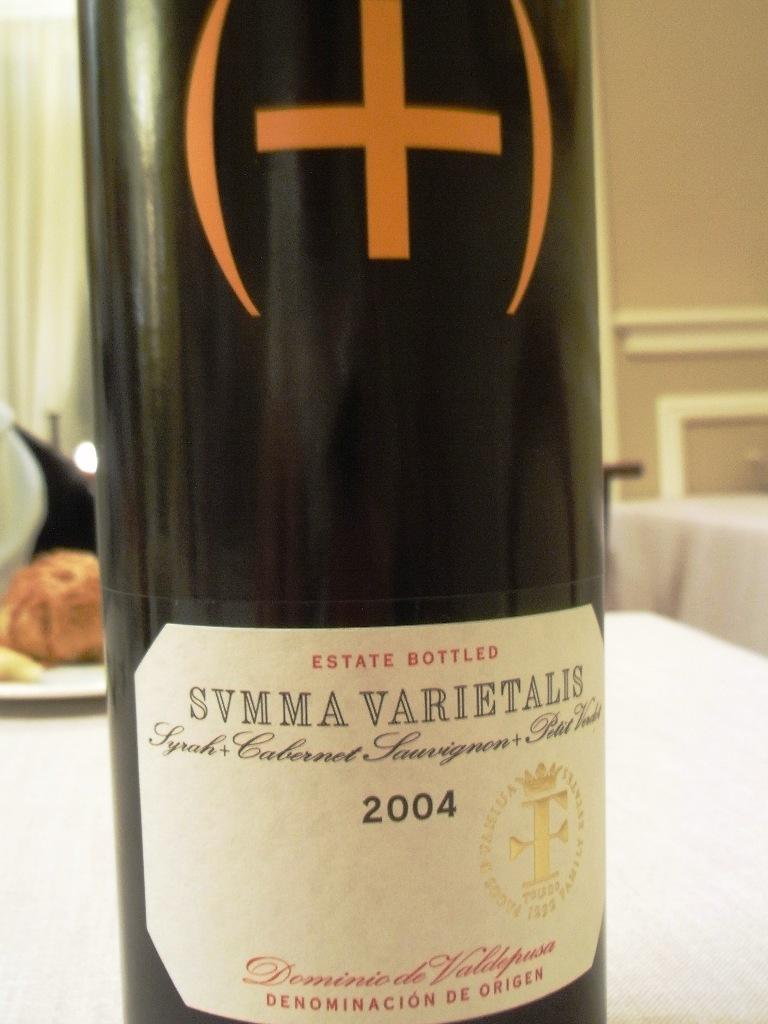<image>
Describe the image concisely. Bottle of wine on a table labeled SVMMA VARIETALIS. 